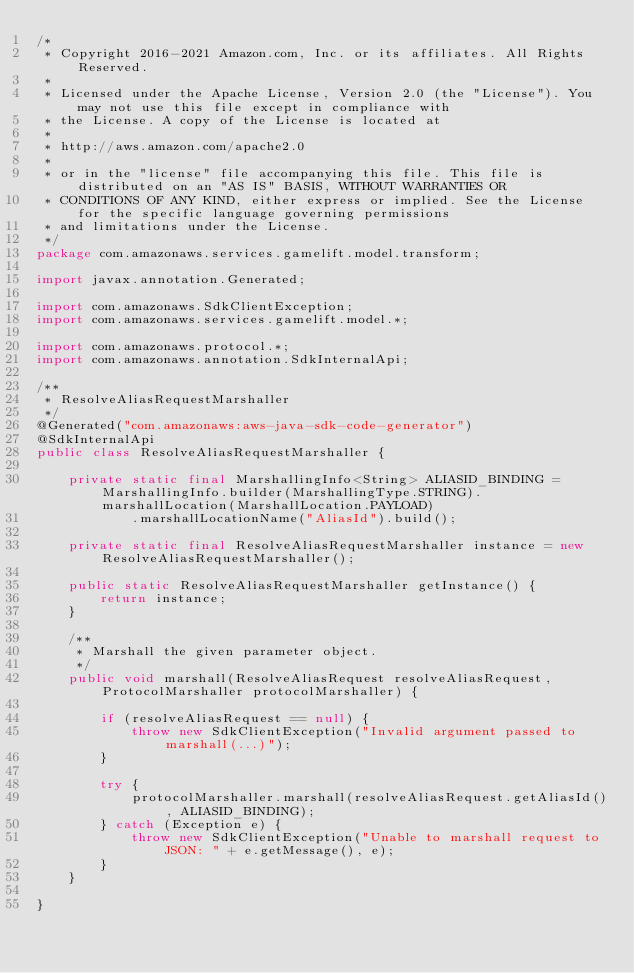<code> <loc_0><loc_0><loc_500><loc_500><_Java_>/*
 * Copyright 2016-2021 Amazon.com, Inc. or its affiliates. All Rights Reserved.
 * 
 * Licensed under the Apache License, Version 2.0 (the "License"). You may not use this file except in compliance with
 * the License. A copy of the License is located at
 * 
 * http://aws.amazon.com/apache2.0
 * 
 * or in the "license" file accompanying this file. This file is distributed on an "AS IS" BASIS, WITHOUT WARRANTIES OR
 * CONDITIONS OF ANY KIND, either express or implied. See the License for the specific language governing permissions
 * and limitations under the License.
 */
package com.amazonaws.services.gamelift.model.transform;

import javax.annotation.Generated;

import com.amazonaws.SdkClientException;
import com.amazonaws.services.gamelift.model.*;

import com.amazonaws.protocol.*;
import com.amazonaws.annotation.SdkInternalApi;

/**
 * ResolveAliasRequestMarshaller
 */
@Generated("com.amazonaws:aws-java-sdk-code-generator")
@SdkInternalApi
public class ResolveAliasRequestMarshaller {

    private static final MarshallingInfo<String> ALIASID_BINDING = MarshallingInfo.builder(MarshallingType.STRING).marshallLocation(MarshallLocation.PAYLOAD)
            .marshallLocationName("AliasId").build();

    private static final ResolveAliasRequestMarshaller instance = new ResolveAliasRequestMarshaller();

    public static ResolveAliasRequestMarshaller getInstance() {
        return instance;
    }

    /**
     * Marshall the given parameter object.
     */
    public void marshall(ResolveAliasRequest resolveAliasRequest, ProtocolMarshaller protocolMarshaller) {

        if (resolveAliasRequest == null) {
            throw new SdkClientException("Invalid argument passed to marshall(...)");
        }

        try {
            protocolMarshaller.marshall(resolveAliasRequest.getAliasId(), ALIASID_BINDING);
        } catch (Exception e) {
            throw new SdkClientException("Unable to marshall request to JSON: " + e.getMessage(), e);
        }
    }

}
</code> 